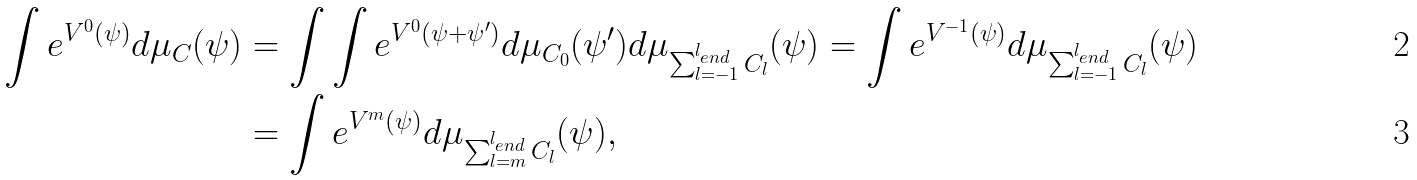<formula> <loc_0><loc_0><loc_500><loc_500>\int e ^ { V ^ { 0 } ( \psi ) } d \mu _ { C } ( \psi ) & = \int \int e ^ { V ^ { 0 } ( \psi + \psi ^ { \prime } ) } d \mu _ { C _ { 0 } } ( \psi ^ { \prime } ) d \mu _ { \sum _ { l = - 1 } ^ { l _ { e n d } } C _ { l } } ( \psi ) = \int e ^ { V ^ { - 1 } ( \psi ) } d \mu _ { \sum _ { l = - 1 } ^ { l _ { e n d } } C _ { l } } ( \psi ) \\ & = \int e ^ { V ^ { m } ( \psi ) } d \mu _ { \sum _ { l = m } ^ { l _ { e n d } } C _ { l } } ( \psi ) ,</formula> 